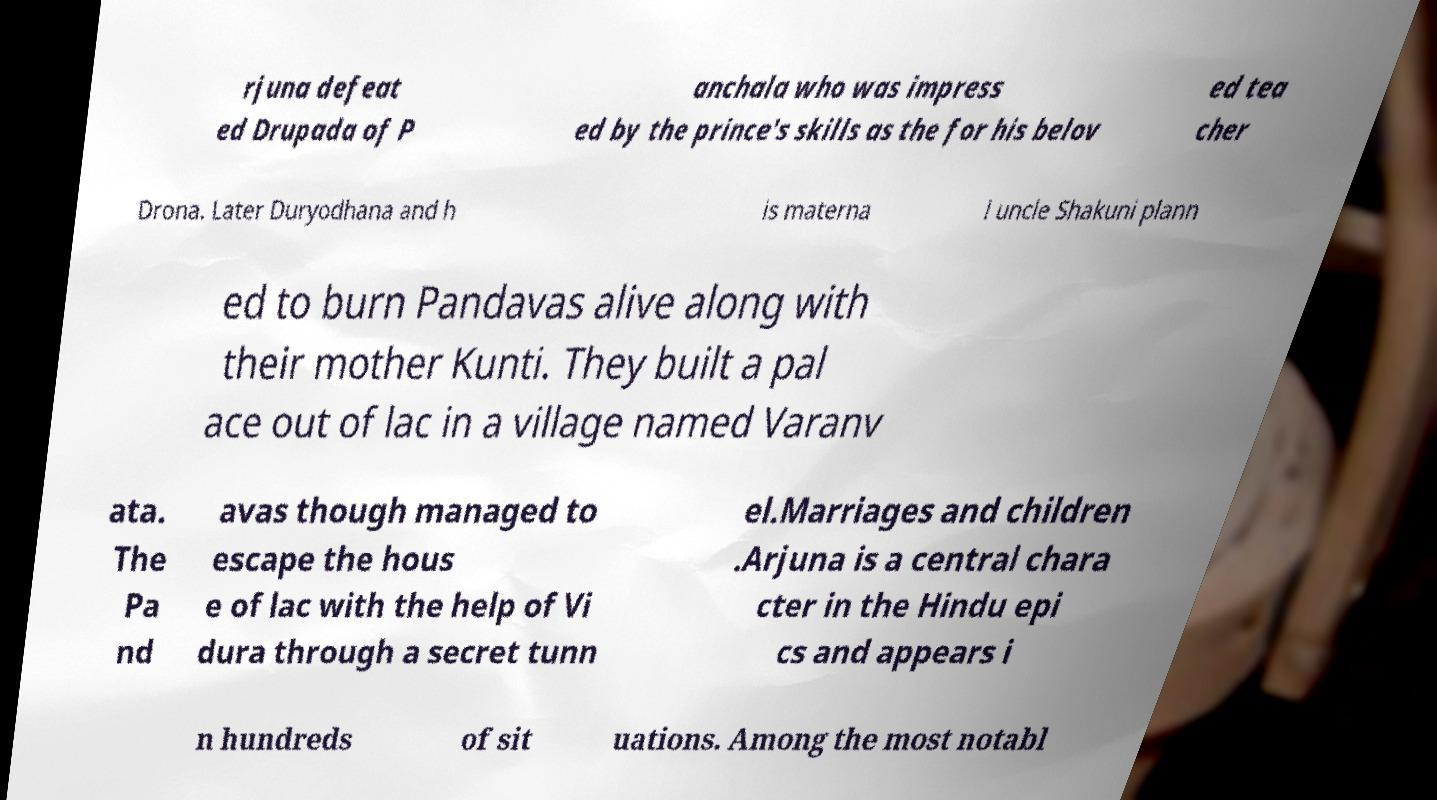Can you read and provide the text displayed in the image?This photo seems to have some interesting text. Can you extract and type it out for me? rjuna defeat ed Drupada of P anchala who was impress ed by the prince's skills as the for his belov ed tea cher Drona. Later Duryodhana and h is materna l uncle Shakuni plann ed to burn Pandavas alive along with their mother Kunti. They built a pal ace out of lac in a village named Varanv ata. The Pa nd avas though managed to escape the hous e of lac with the help of Vi dura through a secret tunn el.Marriages and children .Arjuna is a central chara cter in the Hindu epi cs and appears i n hundreds of sit uations. Among the most notabl 